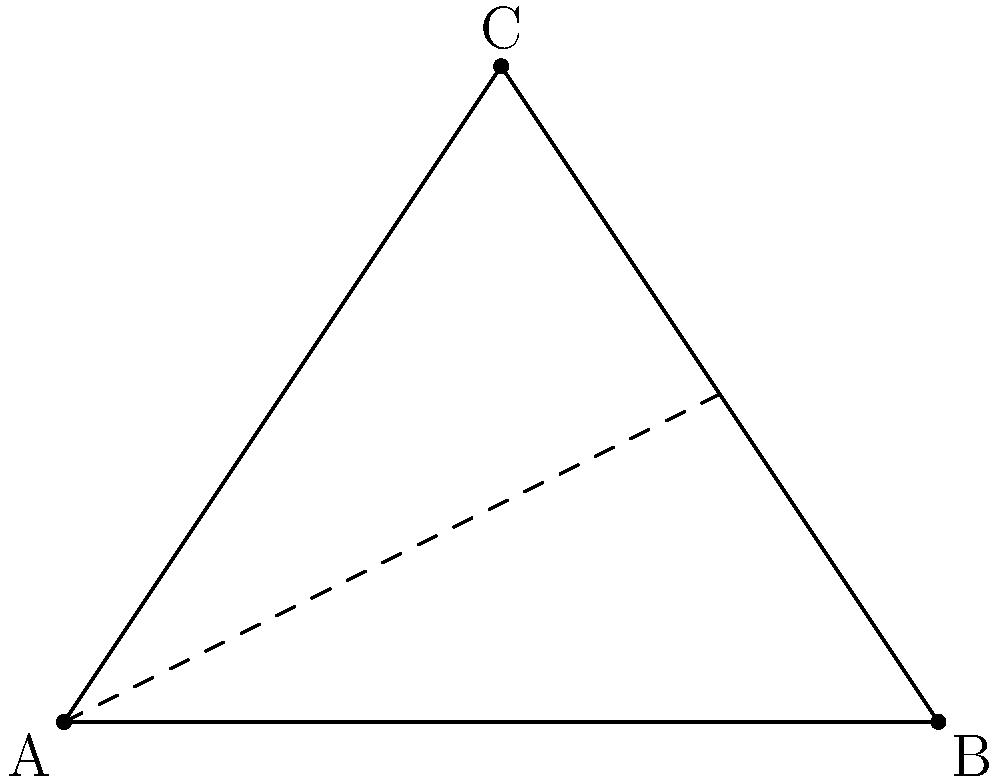In early navigation and cartography, triangulation was a crucial technique for determining distances. Consider the triangle ABC representing a coastal region, where AB is the known baseline of length $d = 10$ km, and the angle at A is measured to be 60°. If the height $h$ of the triangle is 4.33 km, what is the length of the coastline represented by BC (rounded to the nearest km)? To solve this problem, we'll use trigonometry and the Pythagorean theorem:

1) In a 30-60-90 triangle, the ratio of sides is 1 : $\sqrt{3}$ : 2.

2) The triangle ABC is divided into two right triangles by the height $h$.

3) In the right triangle formed by the height:
   $\tan 60° = \frac{h}{d/2}$
   $\sqrt{3} = \frac{h}{5}$
   $h = 5\sqrt{3} \approx 8.66$ km

4) However, we're given that $h = 4.33$ km. This means our triangle is not a full 30-60-90 triangle, but half of it.

5) If $h = 4.33$ km is half the height, then the full height would be 8.66 km, confirming our calculation.

6) Now, we can find half of BC using the Pythagorean theorem:
   $(\frac{BC}{2})^2 = (\frac{d}{2})^2 + h^2$
   $(\frac{BC}{2})^2 = 5^2 + 4.33^2$
   $(\frac{BC}{2})^2 = 25 + 18.7489 = 43.7489$
   $\frac{BC}{2} = \sqrt{43.7489} \approx 6.61$ km

7) Therefore, BC = 2 * 6.61 = 13.22 km

8) Rounding to the nearest km, BC ≈ 13 km.
Answer: 13 km 